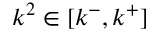Convert formula to latex. <formula><loc_0><loc_0><loc_500><loc_500>k ^ { 2 } \in [ k ^ { - } , k ^ { + } ]</formula> 